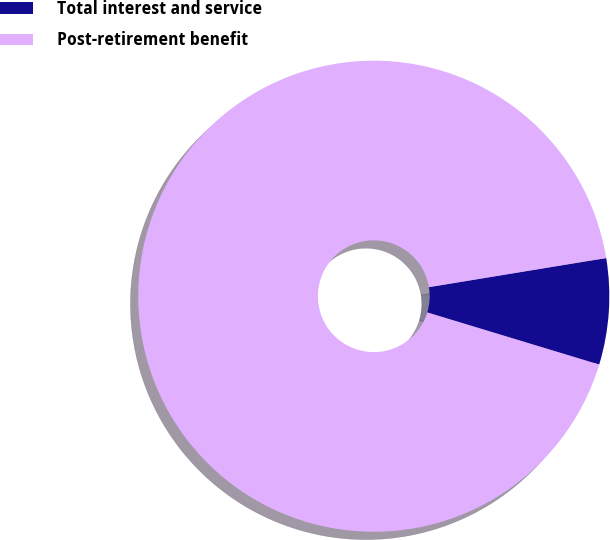<chart> <loc_0><loc_0><loc_500><loc_500><pie_chart><fcel>Total interest and service<fcel>Post-retirement benefit<nl><fcel>7.28%<fcel>92.72%<nl></chart> 